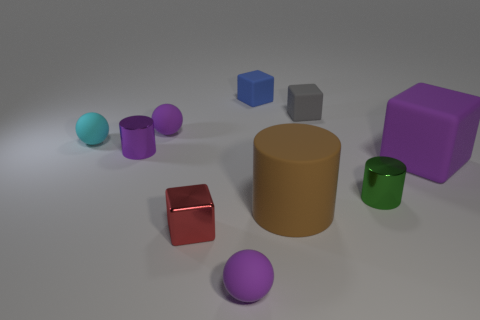There is a cyan matte object; is its shape the same as the purple rubber object that is right of the tiny blue block?
Your answer should be compact. No. The cyan thing has what shape?
Provide a short and direct response. Sphere. There is a purple cylinder that is the same size as the cyan rubber ball; what material is it?
Provide a short and direct response. Metal. How many objects are small rubber spheres or tiny blocks that are behind the tiny red block?
Your answer should be very brief. 5. There is a cylinder that is made of the same material as the purple block; what is its size?
Your answer should be very brief. Large. What shape is the small red shiny object that is in front of the metallic thing behind the purple cube?
Your response must be concise. Cube. How big is the matte object that is both in front of the cyan rubber ball and right of the large brown thing?
Offer a terse response. Large. Is there another metal object that has the same shape as the purple shiny thing?
Provide a succinct answer. Yes. Is there anything else that has the same shape as the blue rubber thing?
Your answer should be very brief. Yes. The small purple thing to the left of the small purple sphere that is on the left side of the tiny rubber object that is in front of the big brown thing is made of what material?
Provide a short and direct response. Metal. 